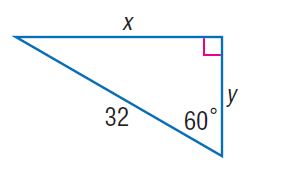Answer the mathemtical geometry problem and directly provide the correct option letter.
Question: Find y.
Choices: A: 8 B: 16 C: 16 \sqrt { 3 } D: 16 \sqrt { 3 } B 